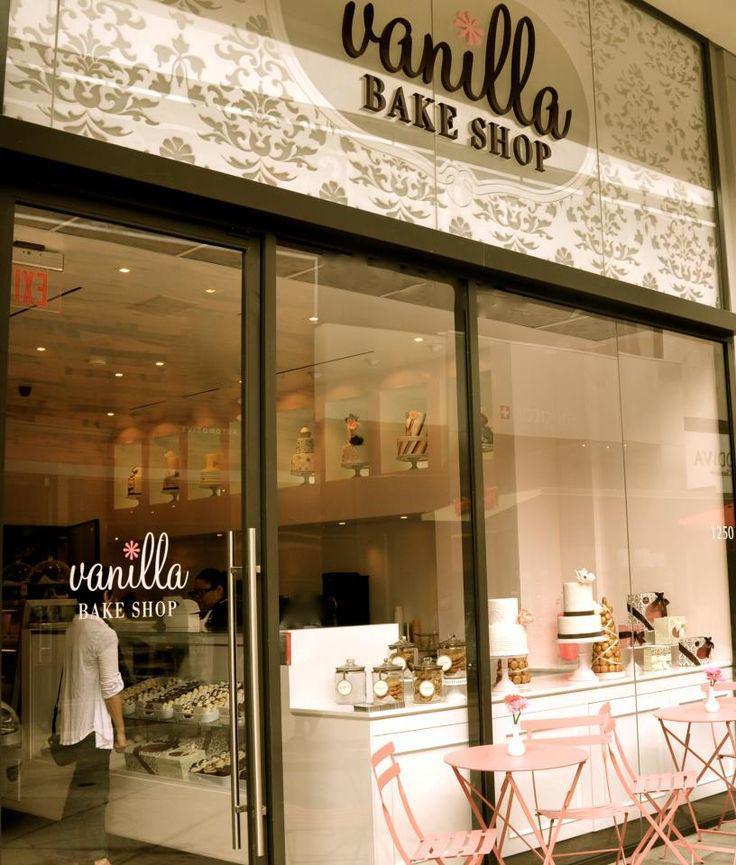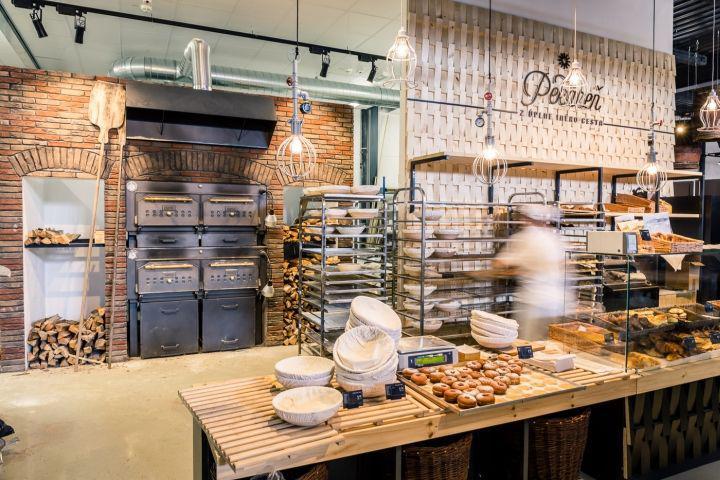The first image is the image on the left, the second image is the image on the right. Given the left and right images, does the statement "A bakery in one image has an indoor seating area for customers." hold true? Answer yes or no. No. 